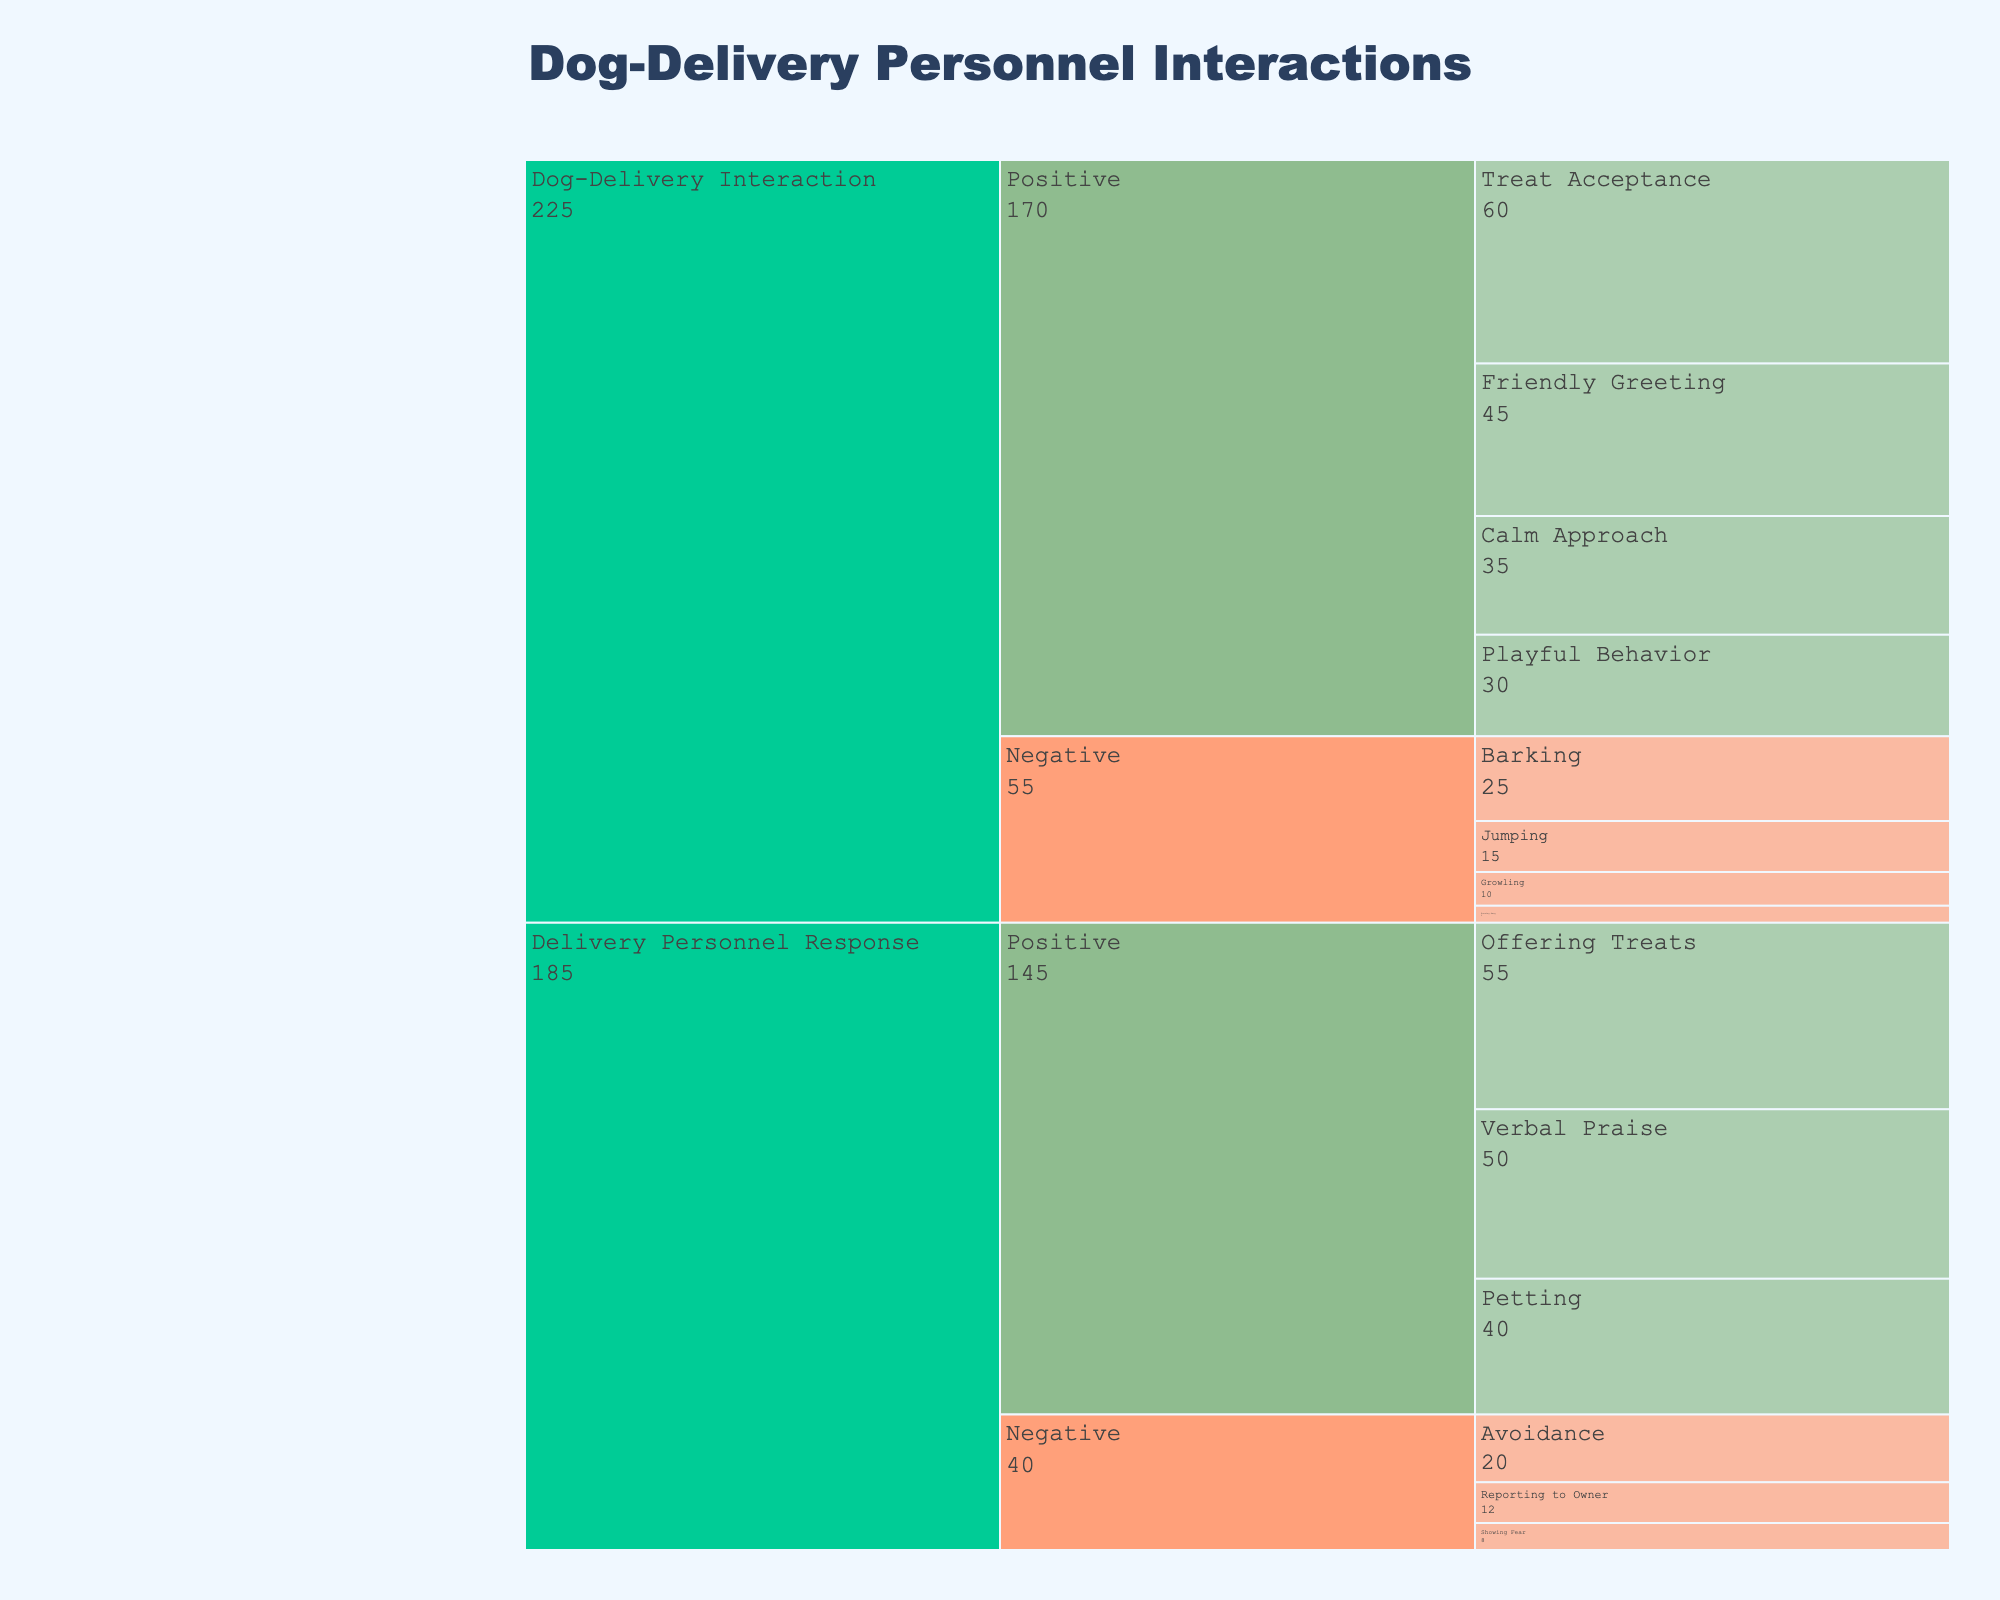What's the title of the figure? The title is prominently displayed at the top of the figure.
Answer: Dog-Delivery Personnel Interactions How many subcategories are under the positive interactions for dogs? By visually inspecting the branches under "Positive" in the "Dog-Delivery Interaction" category, we count the subcategories.
Answer: 4 What is the frequency of dogs barking at delivery personnel? Locate the subcategory "Barking" under the "Negative" interactions for dogs and read the associated frequency.
Answer: 25 What is the total frequency of positive interactions for dogs? Sum the frequencies of all positive subcategories under "Dog-Delivery Interaction": 45 + 60 + 30 + 35.
Answer: 170 Which has the higher frequency: dogs accepting treats or delivery personnel offering treats? Compare the frequency values of "Treat Acceptance" under "Dog-Delivery Interaction" and "Offering Treats" under "Delivery Personnel Response".
Answer: Delivery personnel offering treats What is the difference in frequency between dogs' growling and delivery personnel showing fear? Locate and subtract the frequency of "Showing Fear" under "Delivery Personnel Response" from "Growling" under "Dog-Delivery Interaction".
Answer: 2 Which subcategory under negative interactions for dogs has the lowest frequency? Identify the subcategory with the lowest value under the "Negative" section for "Dog-Delivery Interaction".
Answer: Running Away What is the combined frequency of negative responses from delivery personnel? Add the frequencies of all negative subcategories under "Delivery Personnel Response": 20 + 8 + 12.
Answer: 40 Which positive interaction has more frequency: dogs calming approach or delivery personnel petting? Compare the frequency values of "Calm Approach" under "Dog-Delivery Interaction" and "Petting" under "Delivery Personnel Response".
Answer: Delivery personnel petting Is there a higher total frequency of positive or negative interactions for delivery personnel? Compare the sum of all positive frequencies and all negative frequencies under "Delivery Personnel Response".
Answer: Positive 